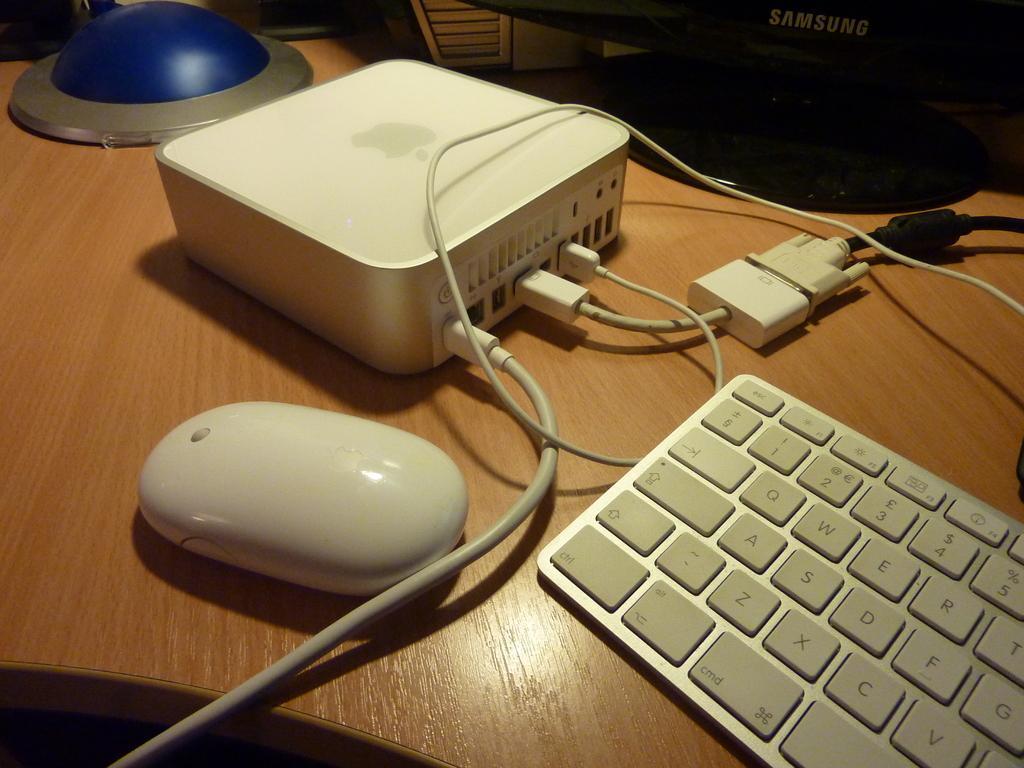Describe this image in one or two sentences. This is the picture of a table on which there is a keyboard, mouse, connector and some other things around. 